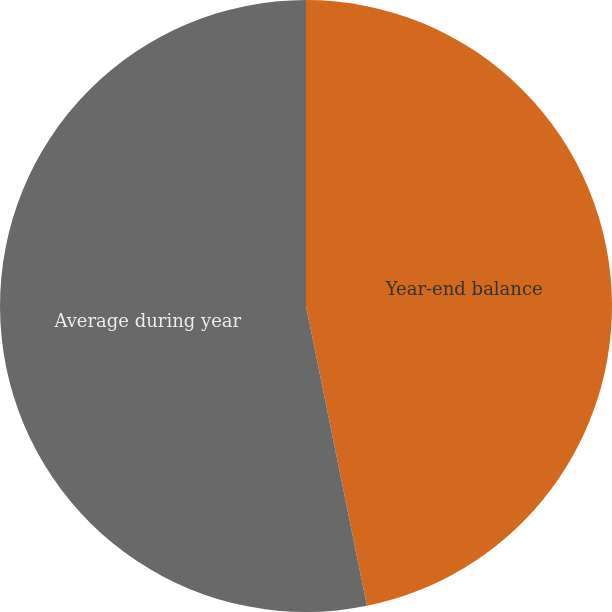<chart> <loc_0><loc_0><loc_500><loc_500><pie_chart><fcel>Year-end balance<fcel>Average during year<nl><fcel>46.81%<fcel>53.19%<nl></chart> 